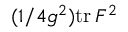<formula> <loc_0><loc_0><loc_500><loc_500>( 1 / 4 g ^ { 2 } ) t r \, F ^ { 2 }</formula> 